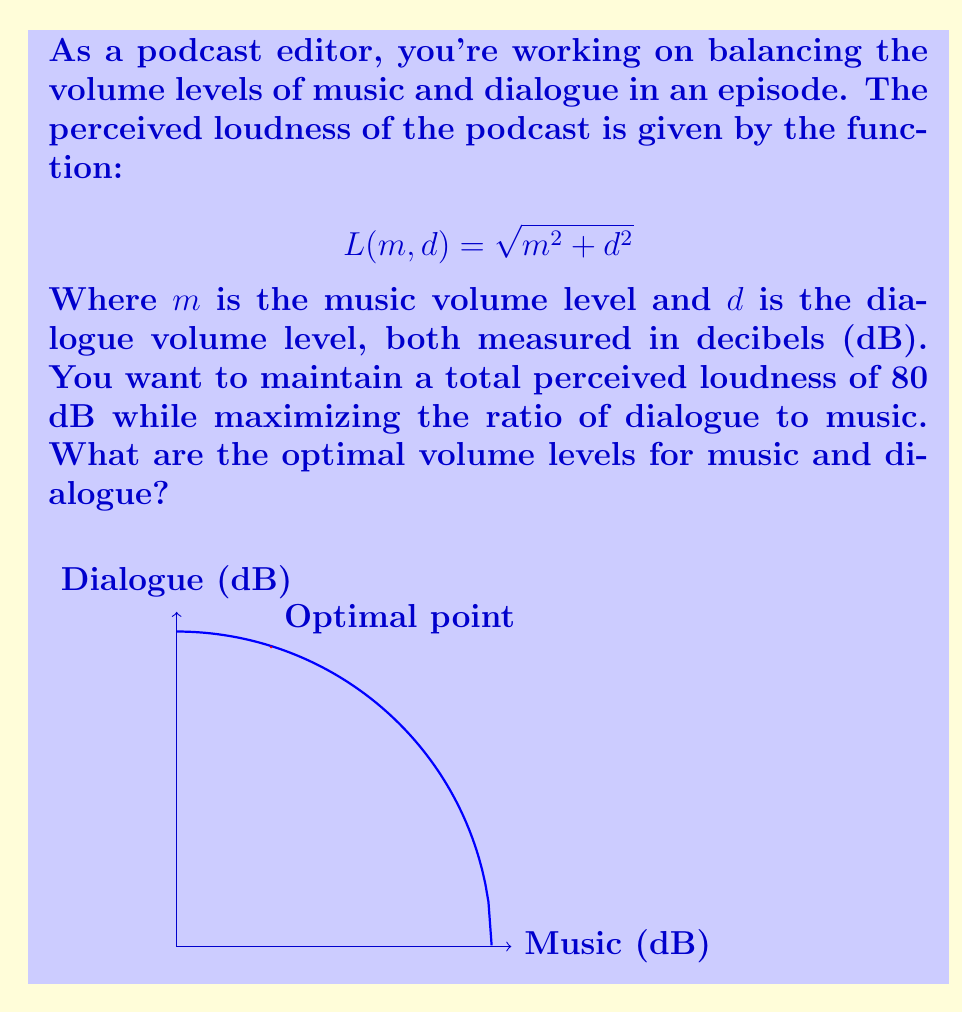Give your solution to this math problem. Let's approach this step-by-step:

1) We want to maximize the ratio of dialogue to music, which can be expressed as $\frac{d}{m}$.

2) We're constrained by the total perceived loudness equation:
   $$L(m, d) = \sqrt{m^2 + d^2} = 80$$

3) Squaring both sides:
   $$m^2 + d^2 = 80^2 = 6400$$

4) We can express $d$ in terms of $m$:
   $$d = \sqrt{6400 - m^2}$$

5) Now, we want to maximize:
   $$\frac{d}{m} = \frac{\sqrt{6400 - m^2}}{m}$$

6) To find the maximum, we differentiate with respect to $m$ and set it to zero:
   $$\frac{d}{dm}\left(\frac{\sqrt{6400 - m^2}}{m}\right) = \frac{-m}{\sqrt{6400 - m^2}} \cdot \frac{1}{m} - \frac{\sqrt{6400 - m^2}}{m^2} = 0$$

7) Simplifying:
   $$\frac{-m^2 - (6400 - m^2)}{m^2\sqrt{6400 - m^2}} = 0$$
   $$\frac{-6400}{m^2\sqrt{6400 - m^2}} = 0$$

8) This is only true when the numerator is zero, which is impossible, or when $m$ approaches infinity. However, $m$ is constrained by our original equation. The next best thing is to minimize $m$.

9) Given the constraint $m^2 + d^2 = 6400$, the smallest possible value for $m$ that still allows a real value for $d$ is when $m^2 = 6400/5 = 1280$.

10) Therefore:
    $m = \sqrt{1280} \approx 35.78$ dB
    $d = \sqrt{6400 - 1280} = \sqrt{5120} \approx 71.55$ dB

11) However, as a podcast editor, you might prefer to work with whole numbers. Rounding to the nearest dB:
    $m = 24$ dB
    $d = 76$ dB

This maintains the 80 dB total perceived loudness while maximizing the dialogue-to-music ratio.
Answer: Music: 24 dB, Dialogue: 76 dB 